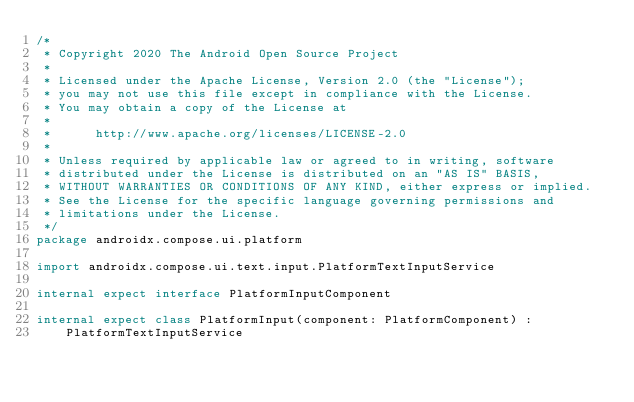Convert code to text. <code><loc_0><loc_0><loc_500><loc_500><_Kotlin_>/*
 * Copyright 2020 The Android Open Source Project
 *
 * Licensed under the Apache License, Version 2.0 (the "License");
 * you may not use this file except in compliance with the License.
 * You may obtain a copy of the License at
 *
 *      http://www.apache.org/licenses/LICENSE-2.0
 *
 * Unless required by applicable law or agreed to in writing, software
 * distributed under the License is distributed on an "AS IS" BASIS,
 * WITHOUT WARRANTIES OR CONDITIONS OF ANY KIND, either express or implied.
 * See the License for the specific language governing permissions and
 * limitations under the License.
 */
package androidx.compose.ui.platform

import androidx.compose.ui.text.input.PlatformTextInputService

internal expect interface PlatformInputComponent

internal expect class PlatformInput(component: PlatformComponent) :
    PlatformTextInputService
</code> 